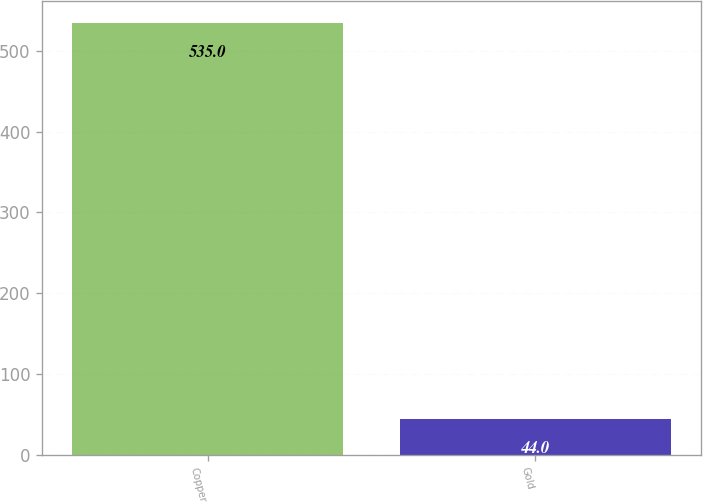<chart> <loc_0><loc_0><loc_500><loc_500><bar_chart><fcel>Copper<fcel>Gold<nl><fcel>535<fcel>44<nl></chart> 